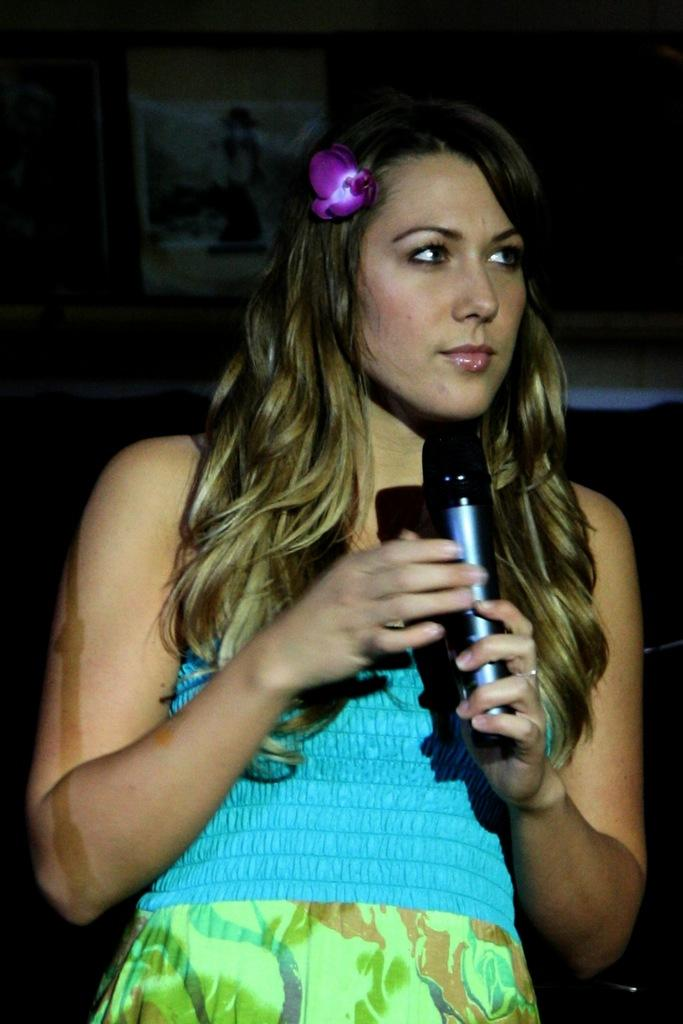What is the main subject of the image? The main subject of the image is a woman. What is the woman holding in her hand? The woman is holding a microphone in her hand. What type of cloth is draped over the engine in the image? There is no engine or cloth present in the image. How many cherries can be seen on the woman's head in the image? There are no cherries present in the image. 